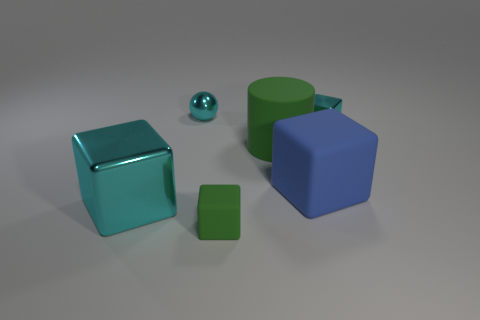Add 4 big gray things. How many objects exist? 10 Subtract all tiny metal blocks. How many blocks are left? 3 Subtract 1 balls. How many balls are left? 0 Subtract all spheres. How many objects are left? 5 Subtract all blue blocks. How many blocks are left? 3 Subtract all large green matte things. Subtract all cyan shiny balls. How many objects are left? 4 Add 2 green matte objects. How many green matte objects are left? 4 Add 3 small green blocks. How many small green blocks exist? 4 Subtract 0 brown blocks. How many objects are left? 6 Subtract all blue cylinders. Subtract all cyan balls. How many cylinders are left? 1 